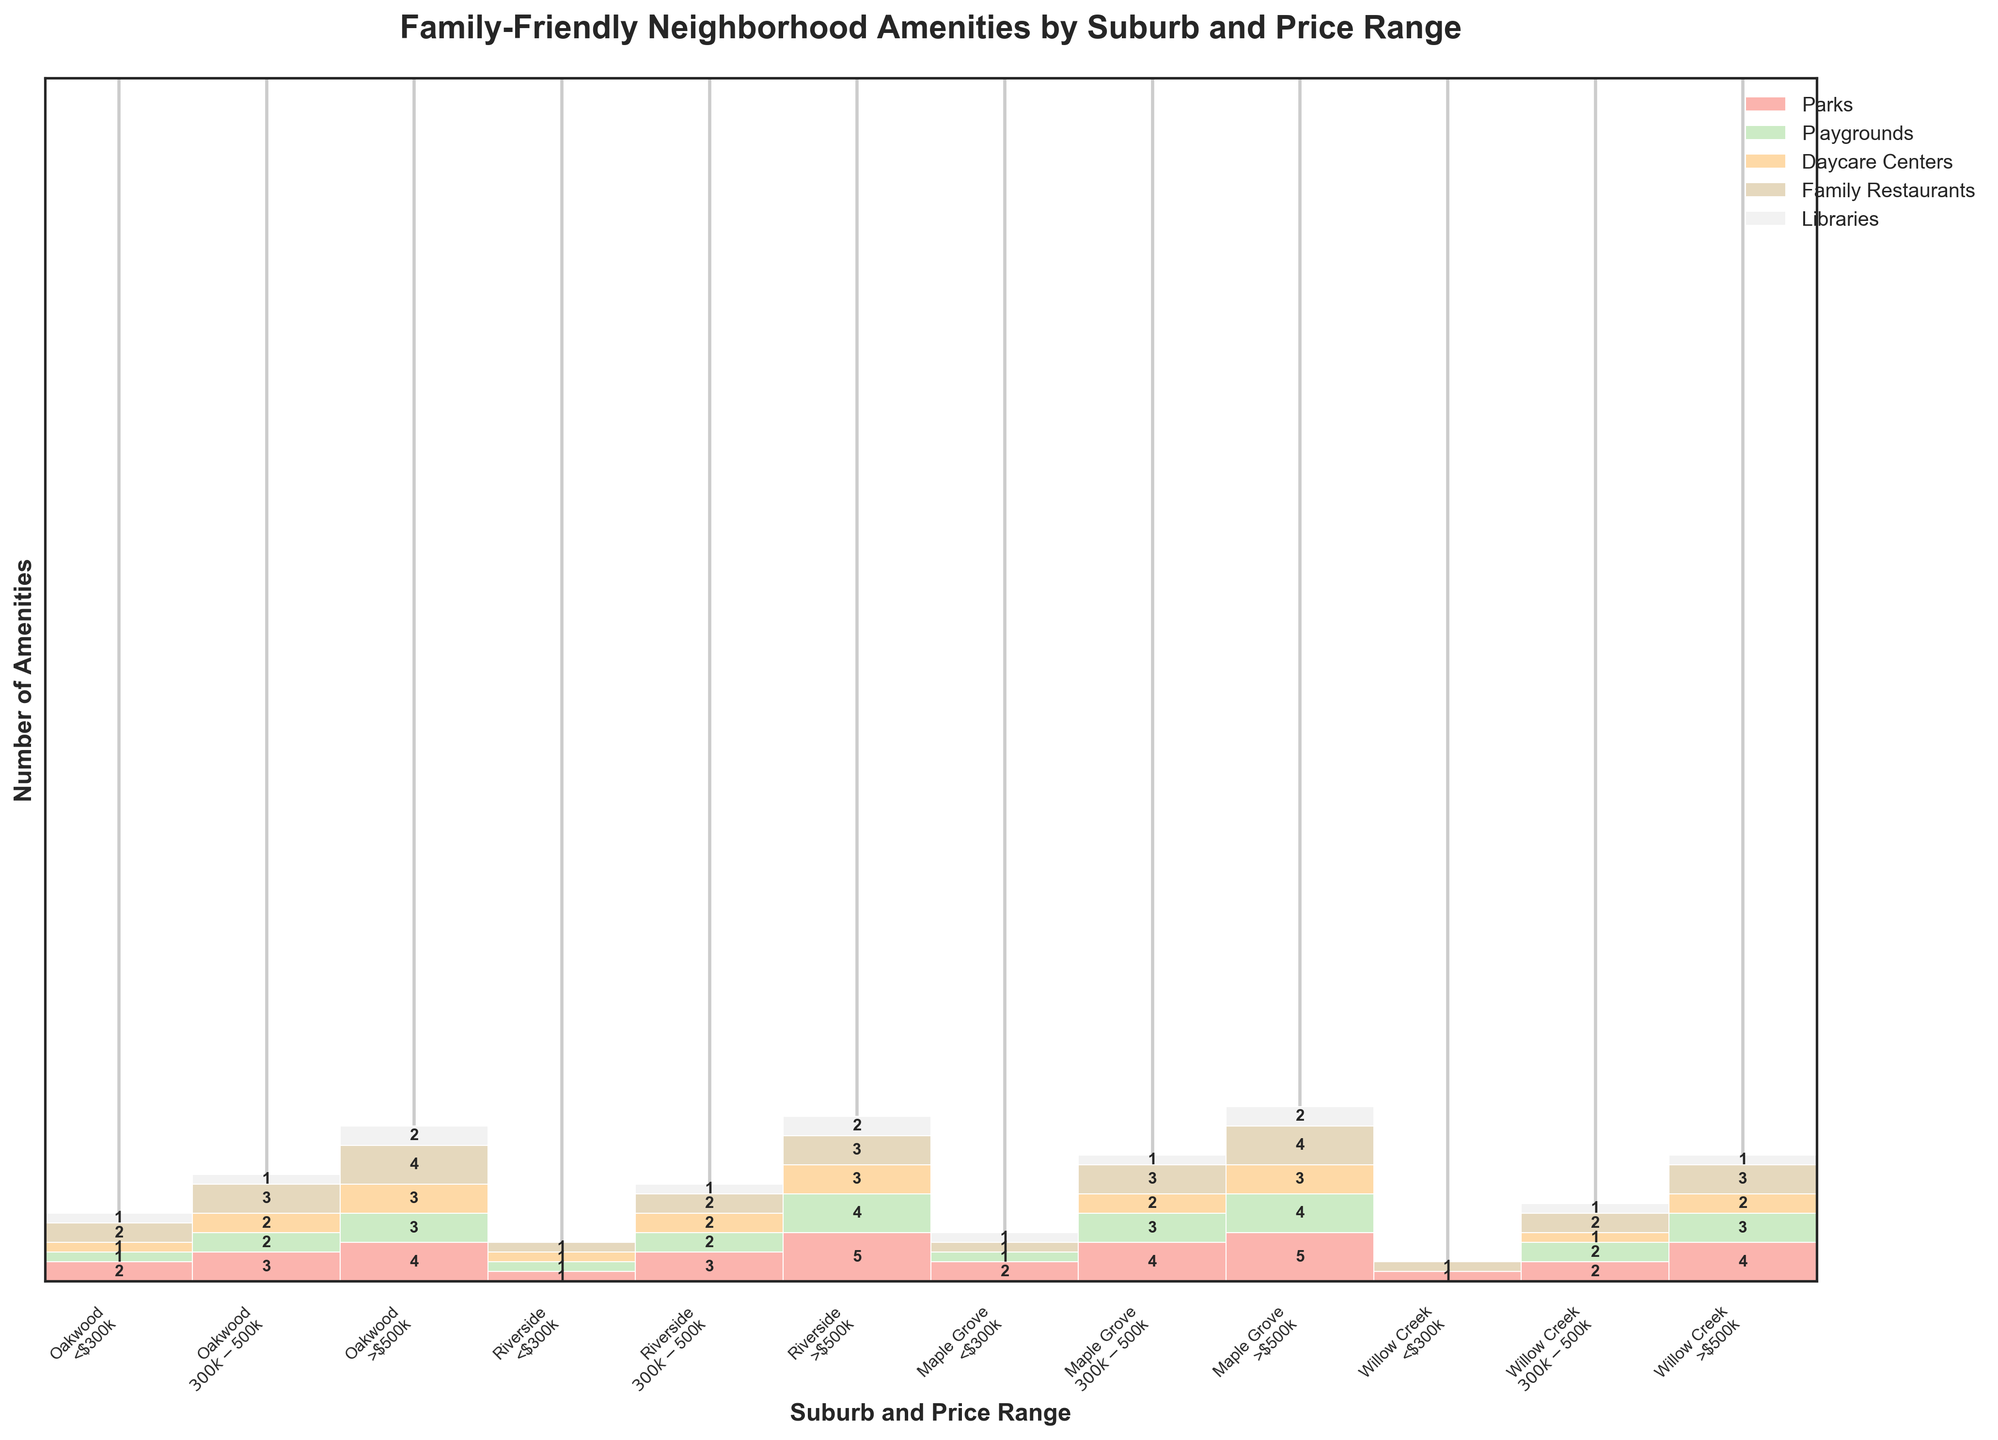Which suburb and price range have the highest number of parks? The highest number of parks can be found by scanning the mosaic plot for the tallest bars in the parks' color (whichever color was assigned to parks). Oakwood in the >$500k price range has the highest number, with a height of 4 units.
Answer: Oakwood, >$500k How many libraries are there in Riverside across all price ranges? To find the total number of libraries in Riverside, sum the individual heights of the library bars for each price range in Riverside. The heights are Riverside <$300k: 0, Riverside $300k-$500k: 1, and Riverside >$500k: 2, making 0 + 1 + 2 = 3.
Answer: 3 Which suburb has the fewest amenities in the <$300k price range? By looking at the total height of all amenities' bars in the <$300k section for each suburb, Willow Creek has the fewest amenities because its bars combined are the shortest.
Answer: Willow Creek Are there more family restaurants in Maple Grove or Riverside in the $300k-$500k price range? Compare the heights of the family restaurant bars in the $300k-$500k price range for Maple Grove and Riverside. Maple Grove has a height of 3 units, while Riverside has a height of 2 units for family restaurants.
Answer: Maple Grove Which suburb has no daycare centers in the <$300k price range? Inspect the heights of the daycare center bars in the <$300k price range for each suburb. Maple Grove and Willow Creek both have a height of 0 units for daycare centers.
Answer: Maple Grove, Willow Creek What is the total number of daycare centers in the >$500k price range across all suburbs? Sum the heights of the daycare center bars in the >$500k price range for each suburb: Oakwood: 3, Riverside: 3, Maple Grove: 3, and Willow Creek: 2. The total is 3 + 3 + 3 + 2 = 11.
Answer: 11 Which suburb in the <$300k price range has the highest number of amenities? Determine which suburb has the tallest combined bars for the <$300k price range. Oakwood has the highest number of amenities with taller bars for each category.
Answer: Oakwood For Oakwood, how does the number of amenities change as the price range increases? Observe the heights of each category's bars for Oakwood across the price ranges: <$300k (total height 7), $300k-$500k (total height 11), >$500k (total height 16). Noticeably, each category's total height increases as the price range increases.
Answer: Increases Which amenity is the most uniformly distributed across all suburbs and price ranges? Examine the height of each bar for each amenity across all suburbs and price ranges. Family Restaurants, with more consistently similar heights, suggest more uniform distribution compared to others.
Answer: Family Restaurants 